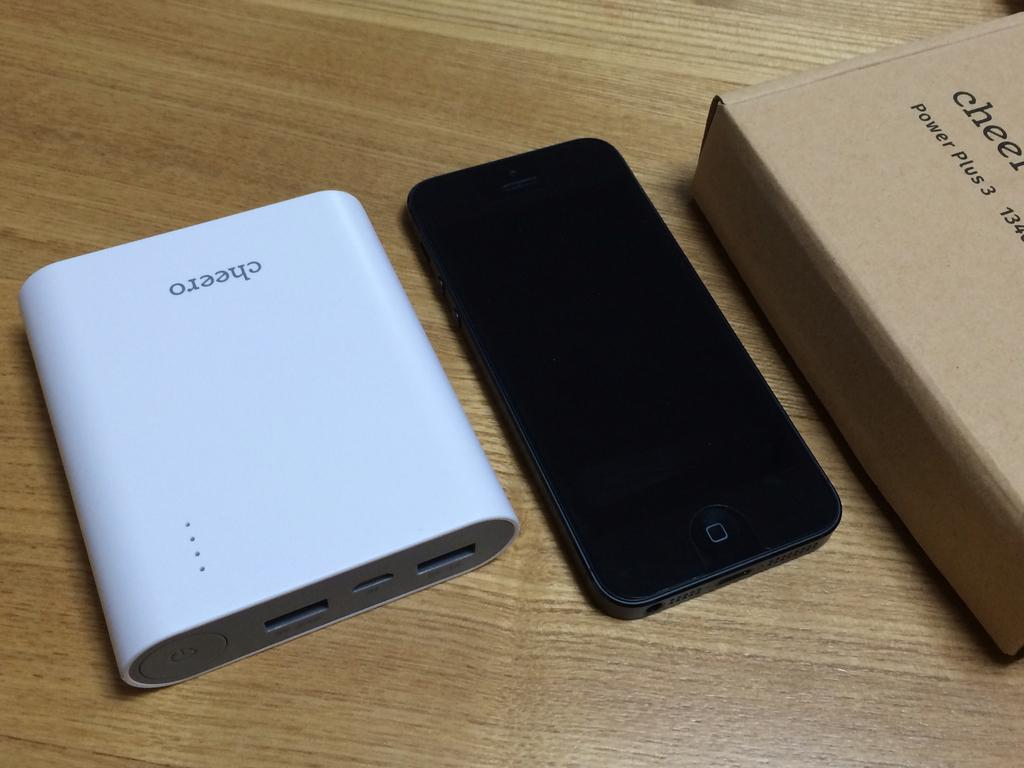<image>
Write a terse but informative summary of the picture. A black cellphone sits between a Cheero power plus 3 and the box the power bank came in. 